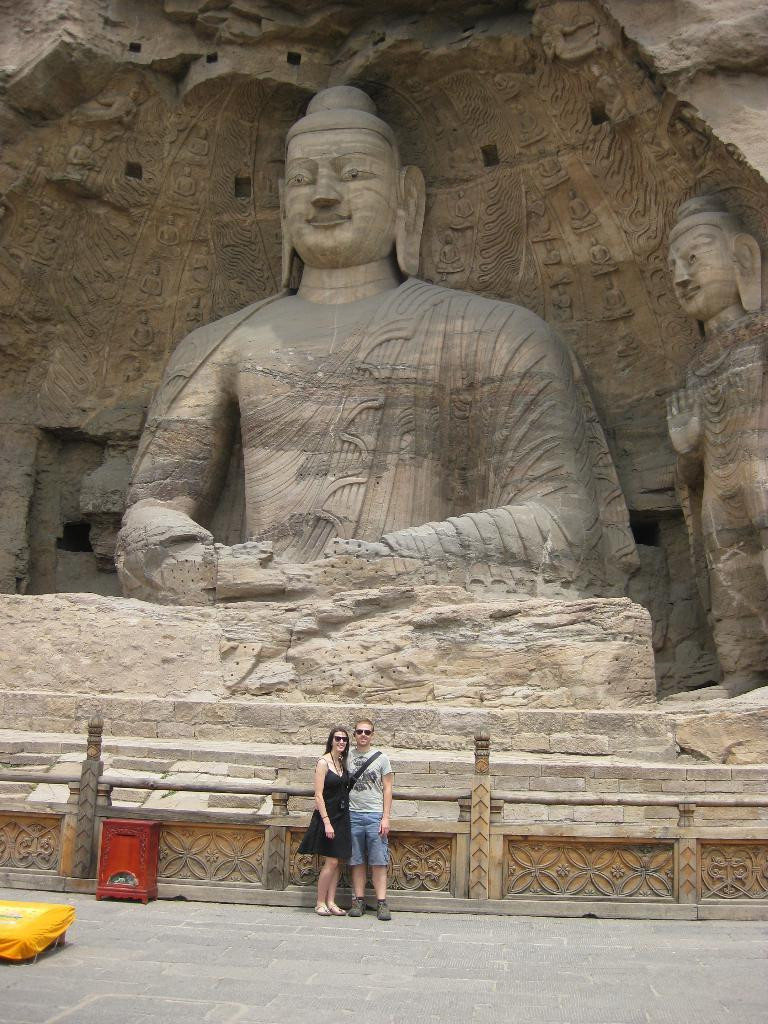How many people are present in the image? There are two people, a man and a woman, present in the image. What are the man and woman doing in the image? The man and woman are standing on a floor in the image. What can be seen in the background of the image? There is a railing and a sculpture in the background of the image. Can you tell me how many goldfish are swimming in the crib in the image? There is no crib or goldfish present in the image. What type of pipe is visible in the image? There is no pipe visible in the image. 